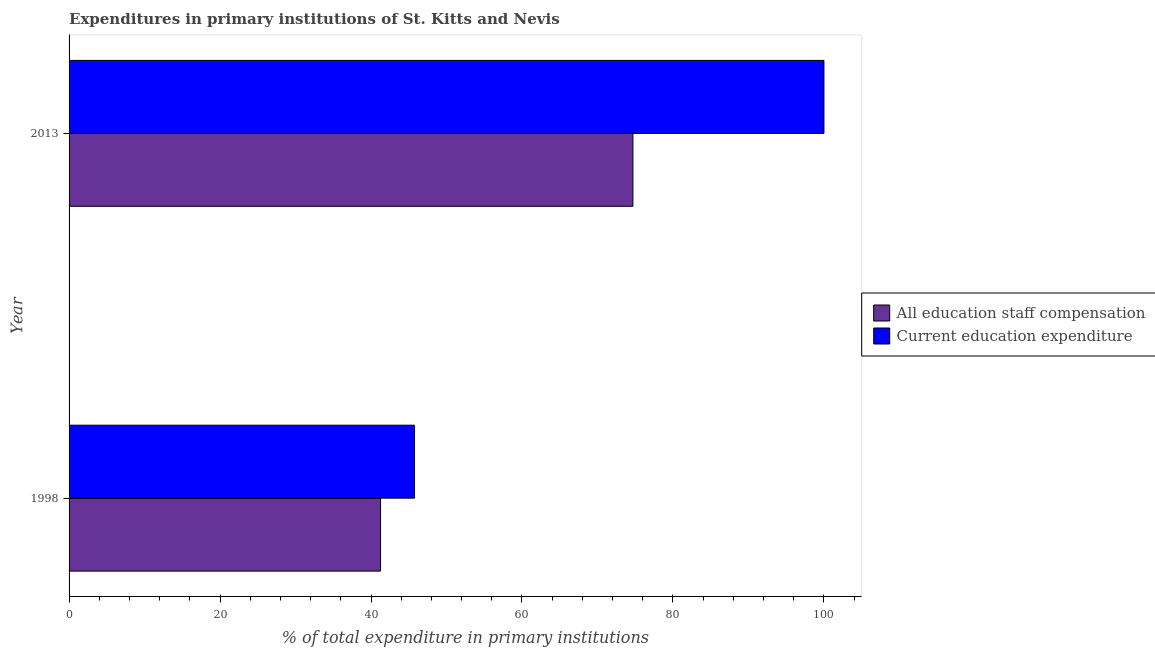How many groups of bars are there?
Your answer should be very brief. 2. Are the number of bars per tick equal to the number of legend labels?
Offer a very short reply. Yes. Are the number of bars on each tick of the Y-axis equal?
Provide a succinct answer. Yes. How many bars are there on the 2nd tick from the bottom?
Ensure brevity in your answer.  2. What is the label of the 1st group of bars from the top?
Provide a short and direct response. 2013. In how many cases, is the number of bars for a given year not equal to the number of legend labels?
Make the answer very short. 0. What is the expenditure in education in 2013?
Give a very brief answer. 100. Across all years, what is the maximum expenditure in staff compensation?
Offer a very short reply. 74.69. Across all years, what is the minimum expenditure in education?
Provide a succinct answer. 45.76. In which year was the expenditure in education maximum?
Provide a succinct answer. 2013. In which year was the expenditure in staff compensation minimum?
Provide a succinct answer. 1998. What is the total expenditure in staff compensation in the graph?
Your response must be concise. 115.96. What is the difference between the expenditure in education in 1998 and that in 2013?
Your answer should be very brief. -54.24. What is the difference between the expenditure in education in 1998 and the expenditure in staff compensation in 2013?
Make the answer very short. -28.93. What is the average expenditure in education per year?
Ensure brevity in your answer.  72.88. In the year 1998, what is the difference between the expenditure in staff compensation and expenditure in education?
Make the answer very short. -4.5. What is the ratio of the expenditure in staff compensation in 1998 to that in 2013?
Your answer should be very brief. 0.55. Is the difference between the expenditure in education in 1998 and 2013 greater than the difference between the expenditure in staff compensation in 1998 and 2013?
Provide a succinct answer. No. What does the 1st bar from the top in 2013 represents?
Make the answer very short. Current education expenditure. What does the 2nd bar from the bottom in 1998 represents?
Give a very brief answer. Current education expenditure. How many bars are there?
Make the answer very short. 4. How many years are there in the graph?
Make the answer very short. 2. Does the graph contain any zero values?
Your answer should be compact. No. Does the graph contain grids?
Provide a succinct answer. No. Where does the legend appear in the graph?
Your response must be concise. Center right. How many legend labels are there?
Provide a short and direct response. 2. What is the title of the graph?
Your response must be concise. Expenditures in primary institutions of St. Kitts and Nevis. What is the label or title of the X-axis?
Ensure brevity in your answer.  % of total expenditure in primary institutions. What is the label or title of the Y-axis?
Keep it short and to the point. Year. What is the % of total expenditure in primary institutions of All education staff compensation in 1998?
Ensure brevity in your answer.  41.26. What is the % of total expenditure in primary institutions in Current education expenditure in 1998?
Offer a terse response. 45.76. What is the % of total expenditure in primary institutions of All education staff compensation in 2013?
Make the answer very short. 74.69. What is the % of total expenditure in primary institutions in Current education expenditure in 2013?
Your answer should be compact. 100. Across all years, what is the maximum % of total expenditure in primary institutions of All education staff compensation?
Your answer should be compact. 74.69. Across all years, what is the minimum % of total expenditure in primary institutions of All education staff compensation?
Your response must be concise. 41.26. Across all years, what is the minimum % of total expenditure in primary institutions of Current education expenditure?
Make the answer very short. 45.76. What is the total % of total expenditure in primary institutions in All education staff compensation in the graph?
Keep it short and to the point. 115.96. What is the total % of total expenditure in primary institutions of Current education expenditure in the graph?
Your answer should be compact. 145.76. What is the difference between the % of total expenditure in primary institutions of All education staff compensation in 1998 and that in 2013?
Your response must be concise. -33.43. What is the difference between the % of total expenditure in primary institutions in Current education expenditure in 1998 and that in 2013?
Provide a short and direct response. -54.24. What is the difference between the % of total expenditure in primary institutions of All education staff compensation in 1998 and the % of total expenditure in primary institutions of Current education expenditure in 2013?
Ensure brevity in your answer.  -58.74. What is the average % of total expenditure in primary institutions in All education staff compensation per year?
Ensure brevity in your answer.  57.98. What is the average % of total expenditure in primary institutions in Current education expenditure per year?
Keep it short and to the point. 72.88. In the year 1998, what is the difference between the % of total expenditure in primary institutions in All education staff compensation and % of total expenditure in primary institutions in Current education expenditure?
Your answer should be very brief. -4.5. In the year 2013, what is the difference between the % of total expenditure in primary institutions of All education staff compensation and % of total expenditure in primary institutions of Current education expenditure?
Your answer should be very brief. -25.31. What is the ratio of the % of total expenditure in primary institutions in All education staff compensation in 1998 to that in 2013?
Your response must be concise. 0.55. What is the ratio of the % of total expenditure in primary institutions of Current education expenditure in 1998 to that in 2013?
Offer a terse response. 0.46. What is the difference between the highest and the second highest % of total expenditure in primary institutions of All education staff compensation?
Your answer should be compact. 33.43. What is the difference between the highest and the second highest % of total expenditure in primary institutions of Current education expenditure?
Offer a very short reply. 54.24. What is the difference between the highest and the lowest % of total expenditure in primary institutions of All education staff compensation?
Make the answer very short. 33.43. What is the difference between the highest and the lowest % of total expenditure in primary institutions in Current education expenditure?
Provide a succinct answer. 54.24. 